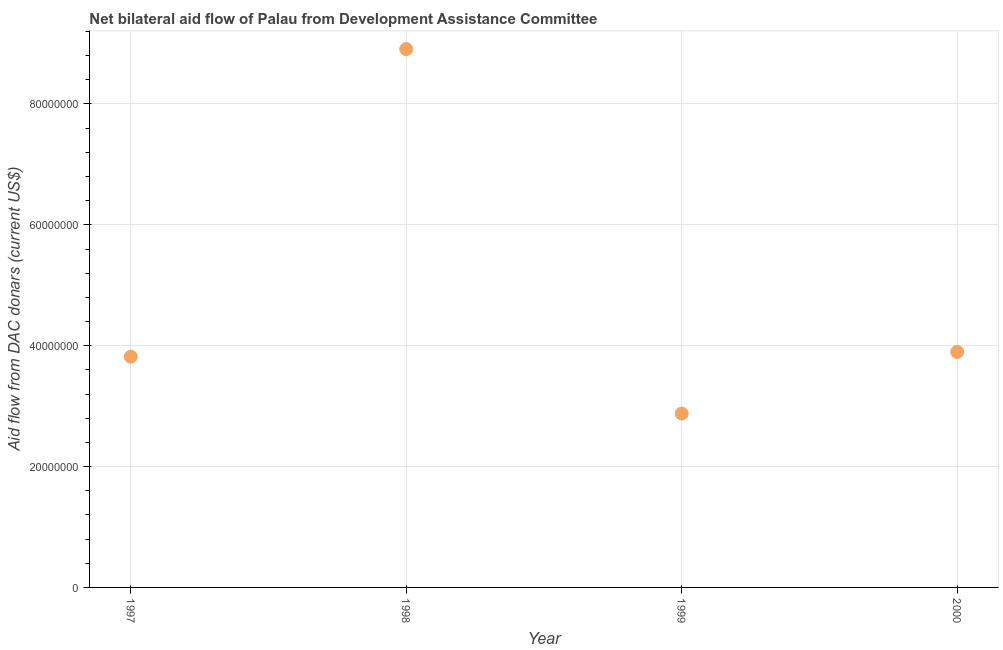What is the net bilateral aid flows from dac donors in 1998?
Make the answer very short. 8.91e+07. Across all years, what is the maximum net bilateral aid flows from dac donors?
Provide a succinct answer. 8.91e+07. Across all years, what is the minimum net bilateral aid flows from dac donors?
Provide a short and direct response. 2.88e+07. What is the sum of the net bilateral aid flows from dac donors?
Provide a short and direct response. 1.95e+08. What is the difference between the net bilateral aid flows from dac donors in 1997 and 2000?
Provide a short and direct response. -7.90e+05. What is the average net bilateral aid flows from dac donors per year?
Give a very brief answer. 4.88e+07. What is the median net bilateral aid flows from dac donors?
Your response must be concise. 3.86e+07. Do a majority of the years between 1999 and 2000 (inclusive) have net bilateral aid flows from dac donors greater than 36000000 US$?
Your response must be concise. No. What is the ratio of the net bilateral aid flows from dac donors in 1998 to that in 1999?
Offer a very short reply. 3.1. What is the difference between the highest and the second highest net bilateral aid flows from dac donors?
Keep it short and to the point. 5.01e+07. Is the sum of the net bilateral aid flows from dac donors in 1998 and 2000 greater than the maximum net bilateral aid flows from dac donors across all years?
Make the answer very short. Yes. What is the difference between the highest and the lowest net bilateral aid flows from dac donors?
Ensure brevity in your answer.  6.03e+07. Does the net bilateral aid flows from dac donors monotonically increase over the years?
Your response must be concise. No. Does the graph contain any zero values?
Your answer should be very brief. No. Does the graph contain grids?
Make the answer very short. Yes. What is the title of the graph?
Make the answer very short. Net bilateral aid flow of Palau from Development Assistance Committee. What is the label or title of the X-axis?
Keep it short and to the point. Year. What is the label or title of the Y-axis?
Keep it short and to the point. Aid flow from DAC donars (current US$). What is the Aid flow from DAC donars (current US$) in 1997?
Ensure brevity in your answer.  3.82e+07. What is the Aid flow from DAC donars (current US$) in 1998?
Your answer should be compact. 8.91e+07. What is the Aid flow from DAC donars (current US$) in 1999?
Keep it short and to the point. 2.88e+07. What is the Aid flow from DAC donars (current US$) in 2000?
Ensure brevity in your answer.  3.90e+07. What is the difference between the Aid flow from DAC donars (current US$) in 1997 and 1998?
Offer a terse response. -5.09e+07. What is the difference between the Aid flow from DAC donars (current US$) in 1997 and 1999?
Ensure brevity in your answer.  9.41e+06. What is the difference between the Aid flow from DAC donars (current US$) in 1997 and 2000?
Provide a succinct answer. -7.90e+05. What is the difference between the Aid flow from DAC donars (current US$) in 1998 and 1999?
Your response must be concise. 6.03e+07. What is the difference between the Aid flow from DAC donars (current US$) in 1998 and 2000?
Offer a terse response. 5.01e+07. What is the difference between the Aid flow from DAC donars (current US$) in 1999 and 2000?
Give a very brief answer. -1.02e+07. What is the ratio of the Aid flow from DAC donars (current US$) in 1997 to that in 1998?
Your answer should be compact. 0.43. What is the ratio of the Aid flow from DAC donars (current US$) in 1997 to that in 1999?
Offer a terse response. 1.33. What is the ratio of the Aid flow from DAC donars (current US$) in 1997 to that in 2000?
Ensure brevity in your answer.  0.98. What is the ratio of the Aid flow from DAC donars (current US$) in 1998 to that in 1999?
Offer a very short reply. 3.1. What is the ratio of the Aid flow from DAC donars (current US$) in 1998 to that in 2000?
Keep it short and to the point. 2.29. What is the ratio of the Aid flow from DAC donars (current US$) in 1999 to that in 2000?
Offer a very short reply. 0.74. 